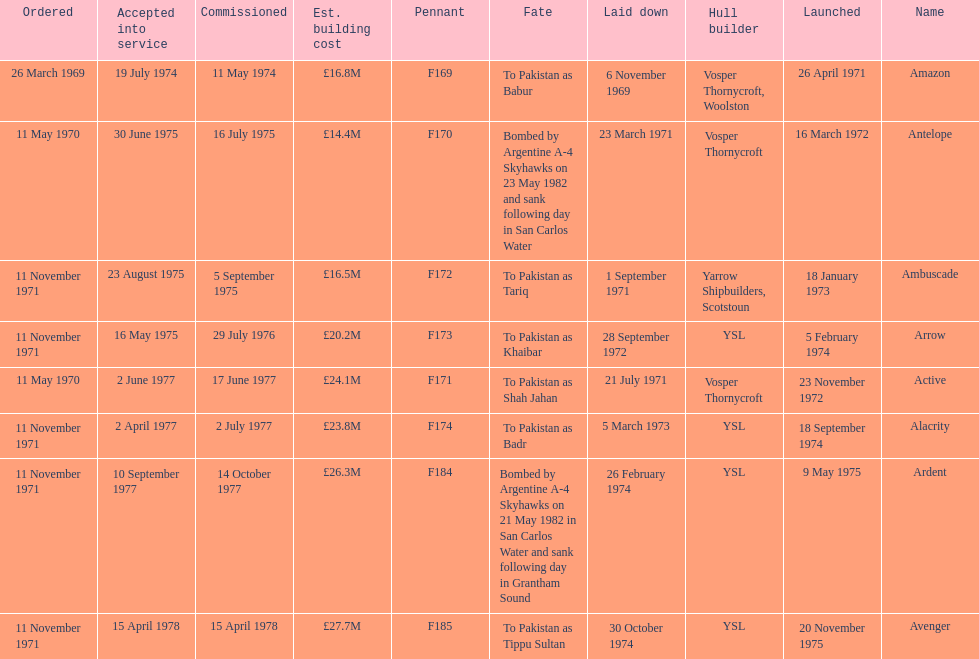What is the name of the ship listed after ardent? Avenger. Can you parse all the data within this table? {'header': ['Ordered', 'Accepted into service', 'Commissioned', 'Est. building cost', 'Pennant', 'Fate', 'Laid down', 'Hull builder', 'Launched', 'Name'], 'rows': [['26 March 1969', '19 July 1974', '11 May 1974', '£16.8M', 'F169', 'To Pakistan as Babur', '6 November 1969', 'Vosper Thornycroft, Woolston', '26 April 1971', 'Amazon'], ['11 May 1970', '30 June 1975', '16 July 1975', '£14.4M', 'F170', 'Bombed by Argentine A-4 Skyhawks on 23 May 1982 and sank following day in San Carlos Water', '23 March 1971', 'Vosper Thornycroft', '16 March 1972', 'Antelope'], ['11 November 1971', '23 August 1975', '5 September 1975', '£16.5M', 'F172', 'To Pakistan as Tariq', '1 September 1971', 'Yarrow Shipbuilders, Scotstoun', '18 January 1973', 'Ambuscade'], ['11 November 1971', '16 May 1975', '29 July 1976', '£20.2M', 'F173', 'To Pakistan as Khaibar', '28 September 1972', 'YSL', '5 February 1974', 'Arrow'], ['11 May 1970', '2 June 1977', '17 June 1977', '£24.1M', 'F171', 'To Pakistan as Shah Jahan', '21 July 1971', 'Vosper Thornycroft', '23 November 1972', 'Active'], ['11 November 1971', '2 April 1977', '2 July 1977', '£23.8M', 'F174', 'To Pakistan as Badr', '5 March 1973', 'YSL', '18 September 1974', 'Alacrity'], ['11 November 1971', '10 September 1977', '14 October 1977', '£26.3M', 'F184', 'Bombed by Argentine A-4 Skyhawks on 21 May 1982 in San Carlos Water and sank following day in Grantham Sound', '26 February 1974', 'YSL', '9 May 1975', 'Ardent'], ['11 November 1971', '15 April 1978', '15 April 1978', '£27.7M', 'F185', 'To Pakistan as Tippu Sultan', '30 October 1974', 'YSL', '20 November 1975', 'Avenger']]} 